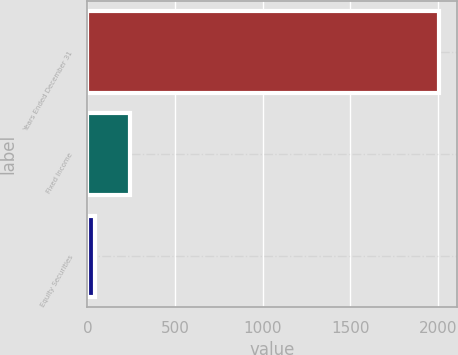Convert chart. <chart><loc_0><loc_0><loc_500><loc_500><bar_chart><fcel>Years Ended December 31<fcel>Fixed Income<fcel>Equity Securities<nl><fcel>2008<fcel>241.3<fcel>45<nl></chart> 